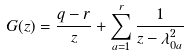<formula> <loc_0><loc_0><loc_500><loc_500>G ( z ) = \frac { q - r } { z } + \sum _ { a = 1 } ^ { r } \frac { 1 } { z - \lambda _ { 0 a } ^ { 2 } }</formula> 